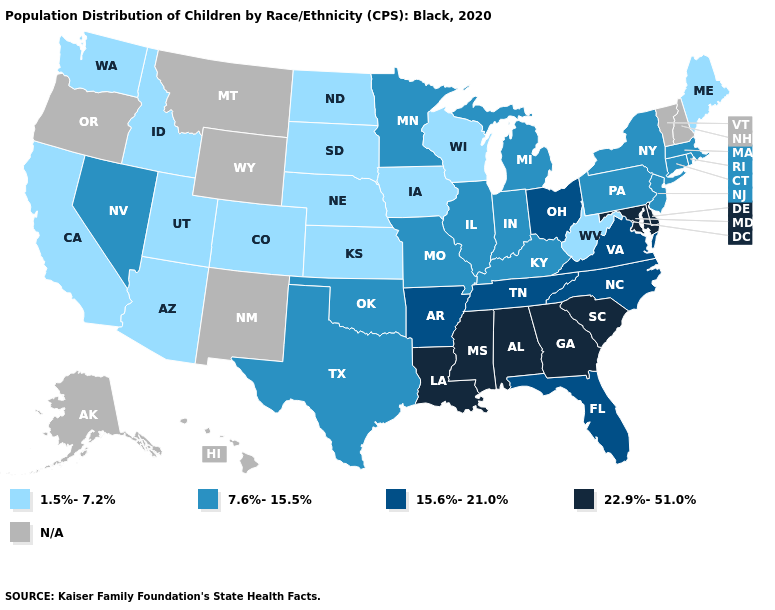Name the states that have a value in the range 15.6%-21.0%?
Quick response, please. Arkansas, Florida, North Carolina, Ohio, Tennessee, Virginia. What is the highest value in the USA?
Short answer required. 22.9%-51.0%. What is the value of West Virginia?
Answer briefly. 1.5%-7.2%. Name the states that have a value in the range 7.6%-15.5%?
Write a very short answer. Connecticut, Illinois, Indiana, Kentucky, Massachusetts, Michigan, Minnesota, Missouri, Nevada, New Jersey, New York, Oklahoma, Pennsylvania, Rhode Island, Texas. Does the first symbol in the legend represent the smallest category?
Write a very short answer. Yes. Does the map have missing data?
Be succinct. Yes. Which states have the lowest value in the Northeast?
Keep it brief. Maine. Is the legend a continuous bar?
Be succinct. No. Among the states that border North Dakota , which have the highest value?
Concise answer only. Minnesota. Does the map have missing data?
Short answer required. Yes. What is the value of Washington?
Keep it brief. 1.5%-7.2%. Which states have the highest value in the USA?
Concise answer only. Alabama, Delaware, Georgia, Louisiana, Maryland, Mississippi, South Carolina. What is the value of Missouri?
Quick response, please. 7.6%-15.5%. Among the states that border Delaware , does New Jersey have the lowest value?
Quick response, please. Yes. What is the lowest value in the USA?
Short answer required. 1.5%-7.2%. 